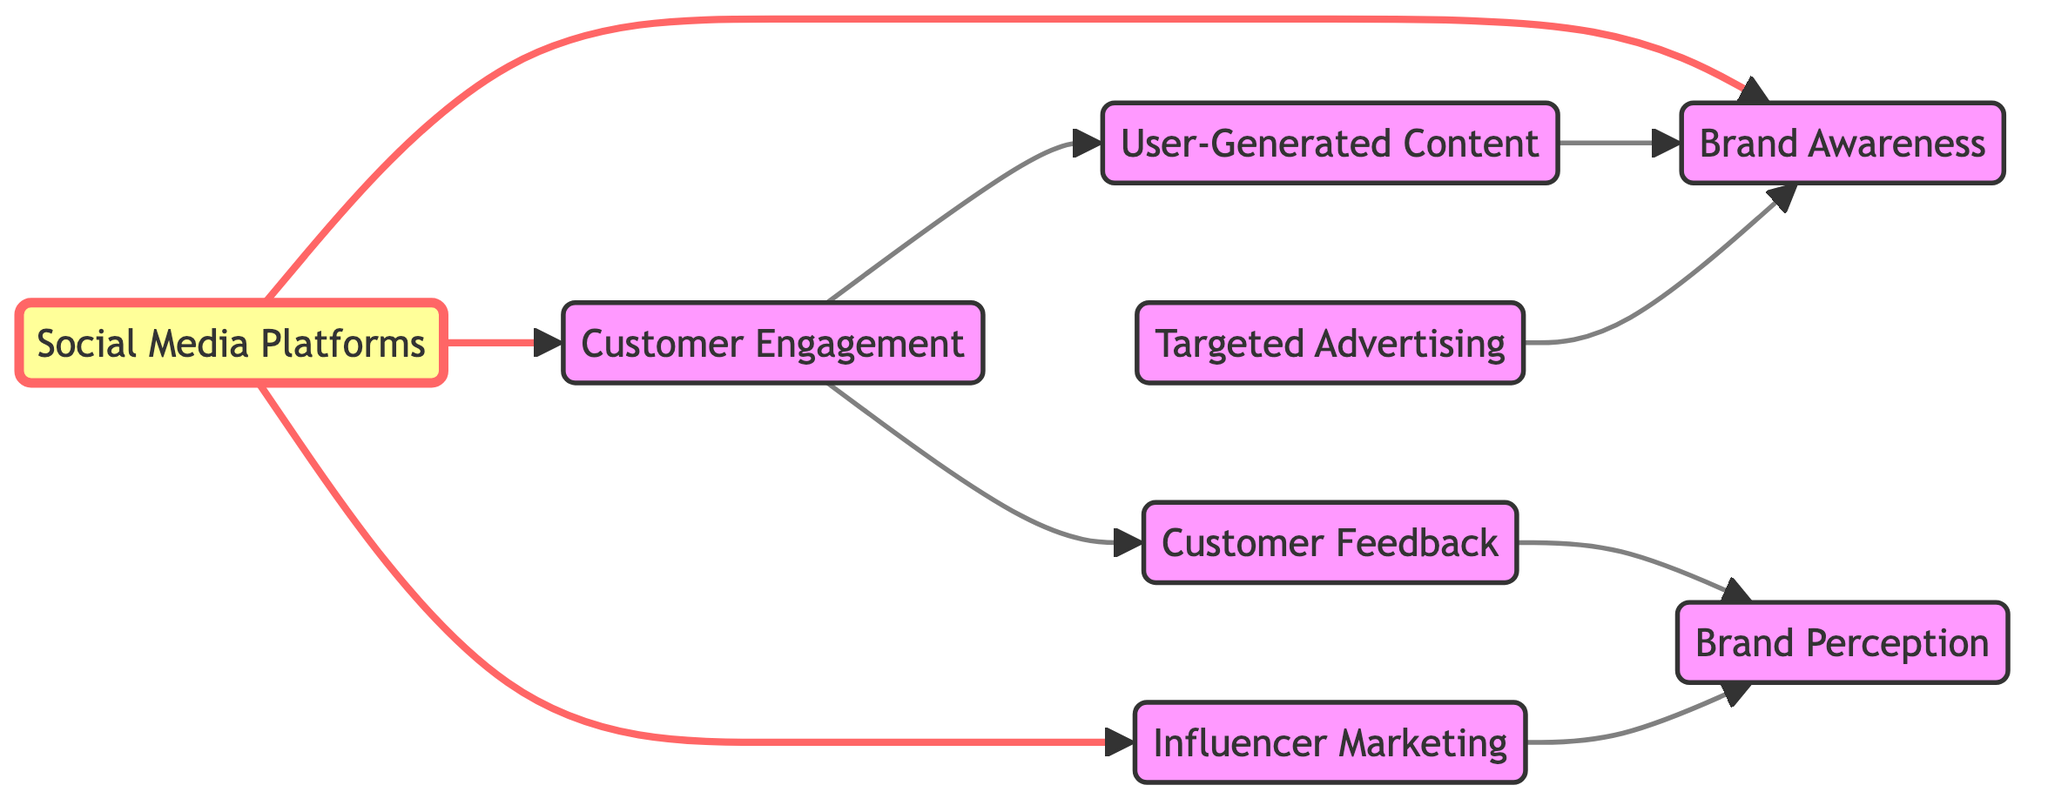What is the total number of nodes in the diagram? The diagram lists 8 distinct nodes, which are Social Media Platforms, Brand Awareness, Customer Engagement, User-Generated Content, Influencer Marketing, Targeted Advertising, Customer Feedback, and Brand Perception. Thus, the total count is 8.
Answer: 8 What node is directly influenced by Customer Engagement? The diagram shows an arrow from Customer Engagement to User-Generated Content, indicating that User-Generated Content is directly influenced by Customer Engagement.
Answer: User-Generated Content Which edges lead to Brand Awareness? There are three direct edges leading to Brand Awareness: from Social Media Platforms, User-Generated Content, and Targeted Advertising. This indicates multiple pathways through which Brand Awareness can be impacted.
Answer: Social Media Platforms, User-Generated Content, Targeted Advertising What influences Brand Perception according to the diagram? Brand Perception is influenced by Influencer Marketing and Customer Feedback, as these nodes have direct edges leading to Brand Perception. This shows that both marketing tactics and customer inputs are crucial for shaping how a brand is perceived.
Answer: Influencer Marketing and Customer Feedback How many edges are there leading from Social Media Platforms? From the diagram, Social Media Platforms has three outgoing edges: one to Brand Awareness, one to Customer Engagement, and one to Influencer Marketing. This indicates that this node acts as a central hub for influencing various outcomes.
Answer: 3 What is the sequence leading from Customer Engagement to Brand Awareness? The flow starts at Customer Engagement, which leads to User-Generated Content, and then User-Generated Content connects to Brand Awareness. Therefore, the sequence is Customer Engagement → User-Generated Content → Brand Awareness.
Answer: Customer Engagement → User-Generated Content → Brand Awareness Which node does Targeted Advertising directly connect to? According to the diagram, Targeted Advertising has a direct edge that connects specifically to Brand Awareness, highlighting its role in enhancing visibility or recognition of a brand.
Answer: Brand Awareness What is the relationship between Customer Engagement and Customer Feedback? The diagram shows a direct edge from Customer Engagement to Customer Feedback, indicating that as customer engagement increases, feedback from customers also develops as a result.
Answer: Customer Engagement influences Customer Feedback What type of content is indicated as influential for Brand Awareness? User-Generated Content is shown to be influential for Brand Awareness because it has a directed edge connecting it to Brand Awareness, suggesting that content created by users helps increase how well a brand is recognized.
Answer: User-Generated Content 